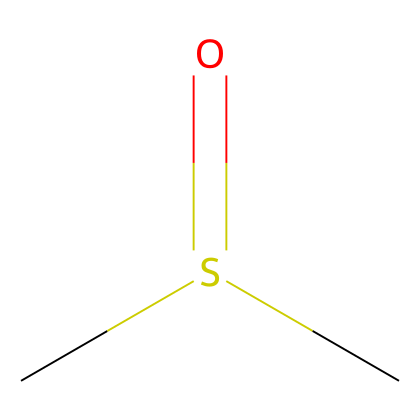What is the molecular formula of dimethyl sulfoxide? The SMILES representation shows two carbon atoms (C), one sulfur atom (S), and one oxygen atom (O) in the structure, corresponding to the molecular formula C2H6OS.
Answer: C2H6OS How many carbon atoms are present in this chemical structure? By examining the SMILES representation, we can count the number of 'C' characters. There are two 'C' characters, indicating there are two carbon atoms.
Answer: 2 What is the functional group present in dimethyl sulfoxide? The chemical structure contains a sulfur atom double-bonded to an oxygen atom (S=O), which indicates the presence of a sulfoxide functional group.
Answer: sulfoxide How many hydrogen atoms are in the molecular composition? The chemical structure has two carbon atoms, which are connected to a total of six hydrogen atoms (each carbon in dimethyl sulfoxide is bonded to three hydrogen atoms). Therefore, the total number of hydrogen atoms is six.
Answer: 6 What type of compound is dimethyl sulfoxide? The presence of sulfur, carbon, and oxygen atoms along with the specific arrangement indicates that this chemical is classified as a sulfur compound, specifically a sulfoxide.
Answer: sulfoxide Is dimethyl sulfoxide polar or nonpolar? The presence of the polar S=O functional group in the dimethyl sulfoxide structure indicates that it is a polar molecule due to differences in electronegativity between sulfur and oxygen.
Answer: polar 